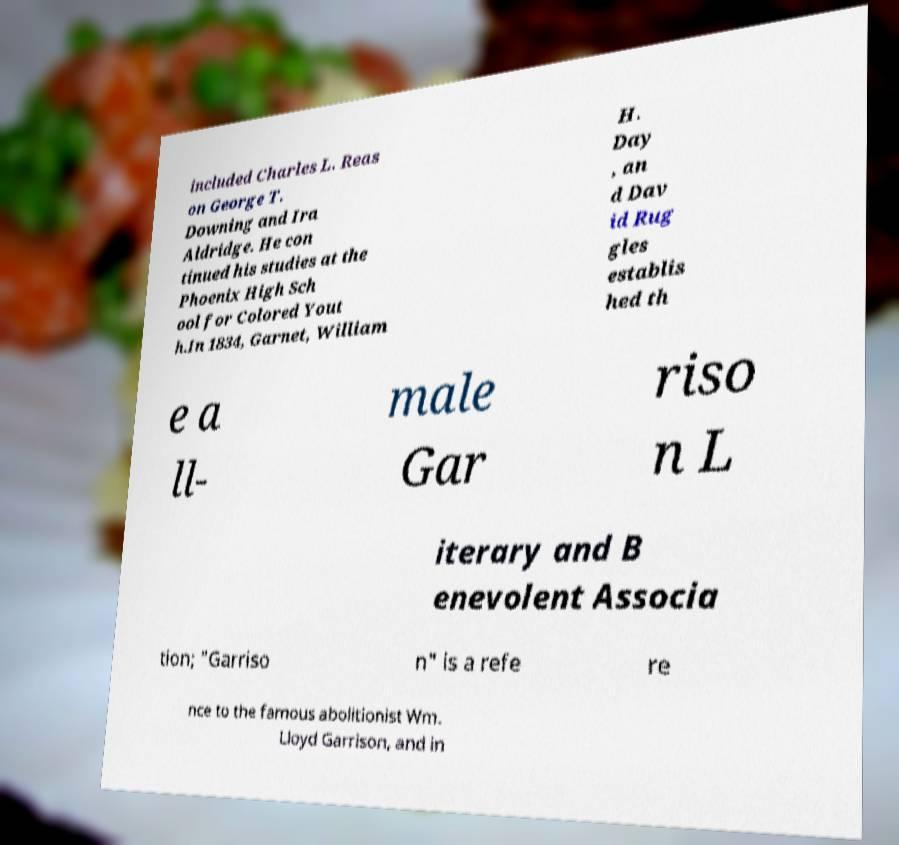Can you read and provide the text displayed in the image?This photo seems to have some interesting text. Can you extract and type it out for me? included Charles L. Reas on George T. Downing and Ira Aldridge. He con tinued his studies at the Phoenix High Sch ool for Colored Yout h.In 1834, Garnet, William H. Day , an d Dav id Rug gles establis hed th e a ll- male Gar riso n L iterary and B enevolent Associa tion; "Garriso n" is a refe re nce to the famous abolitionist Wm. Lloyd Garrison, and in 